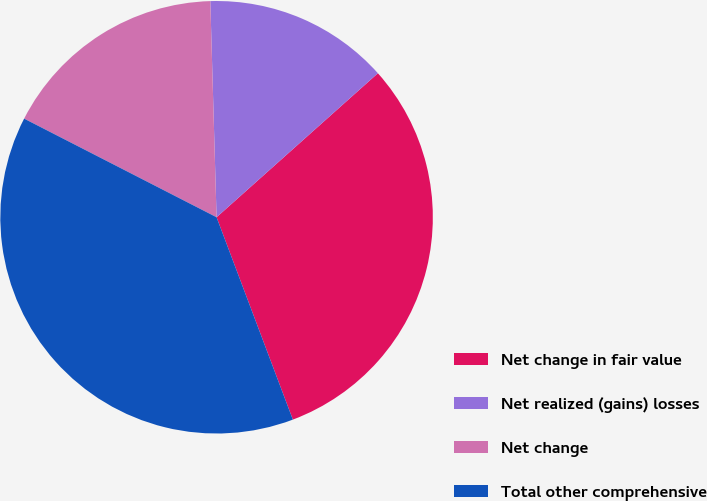<chart> <loc_0><loc_0><loc_500><loc_500><pie_chart><fcel>Net change in fair value<fcel>Net realized (gains) losses<fcel>Net change<fcel>Total other comprehensive<nl><fcel>30.86%<fcel>13.86%<fcel>17.0%<fcel>38.27%<nl></chart> 